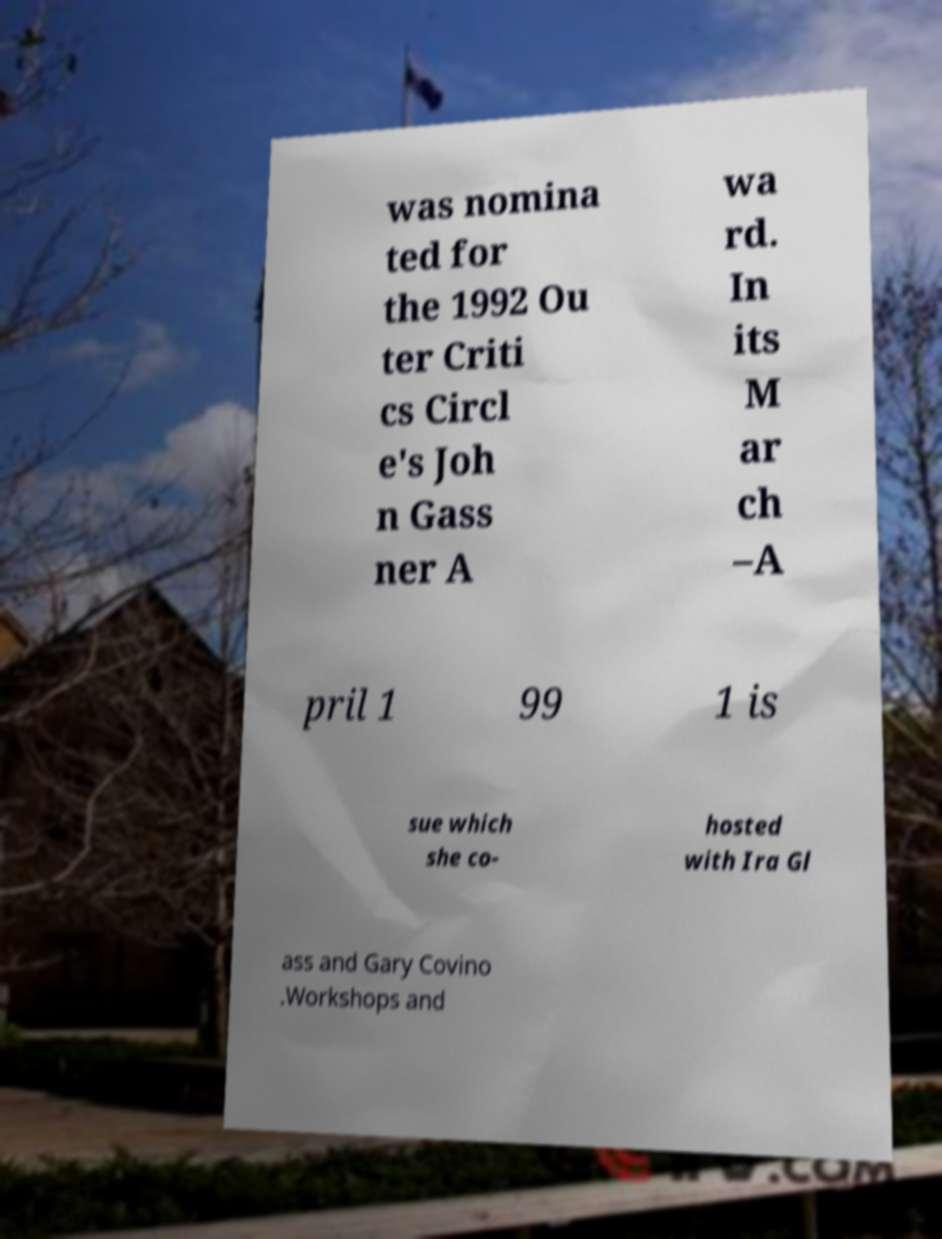Can you read and provide the text displayed in the image?This photo seems to have some interesting text. Can you extract and type it out for me? was nomina ted for the 1992 Ou ter Criti cs Circl e's Joh n Gass ner A wa rd. In its M ar ch –A pril 1 99 1 is sue which she co- hosted with Ira Gl ass and Gary Covino .Workshops and 